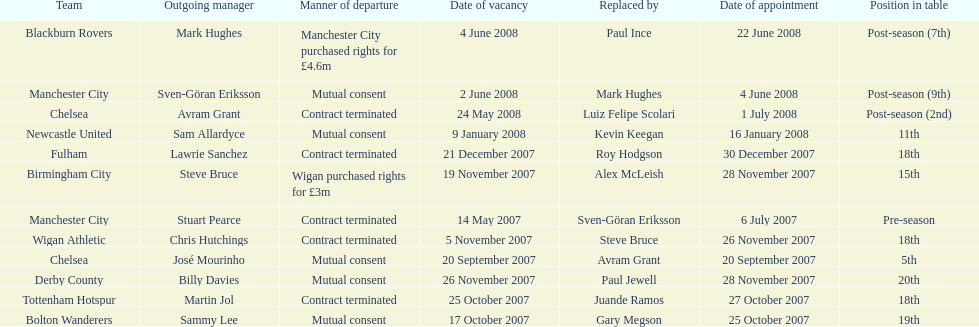Can you parse all the data within this table? {'header': ['Team', 'Outgoing manager', 'Manner of departure', 'Date of vacancy', 'Replaced by', 'Date of appointment', 'Position in table'], 'rows': [['Blackburn Rovers', 'Mark Hughes', 'Manchester City purchased rights for £4.6m', '4 June 2008', 'Paul Ince', '22 June 2008', 'Post-season (7th)'], ['Manchester City', 'Sven-Göran Eriksson', 'Mutual consent', '2 June 2008', 'Mark Hughes', '4 June 2008', 'Post-season (9th)'], ['Chelsea', 'Avram Grant', 'Contract terminated', '24 May 2008', 'Luiz Felipe Scolari', '1 July 2008', 'Post-season (2nd)'], ['Newcastle United', 'Sam Allardyce', 'Mutual consent', '9 January 2008', 'Kevin Keegan', '16 January 2008', '11th'], ['Fulham', 'Lawrie Sanchez', 'Contract terminated', '21 December 2007', 'Roy Hodgson', '30 December 2007', '18th'], ['Birmingham City', 'Steve Bruce', 'Wigan purchased rights for £3m', '19 November 2007', 'Alex McLeish', '28 November 2007', '15th'], ['Manchester City', 'Stuart Pearce', 'Contract terminated', '14 May 2007', 'Sven-Göran Eriksson', '6 July 2007', 'Pre-season'], ['Wigan Athletic', 'Chris Hutchings', 'Contract terminated', '5 November 2007', 'Steve Bruce', '26 November 2007', '18th'], ['Chelsea', 'José Mourinho', 'Mutual consent', '20 September 2007', 'Avram Grant', '20 September 2007', '5th'], ['Derby County', 'Billy Davies', 'Mutual consent', '26 November 2007', 'Paul Jewell', '28 November 2007', '20th'], ['Tottenham Hotspur', 'Martin Jol', 'Contract terminated', '25 October 2007', 'Juande Ramos', '27 October 2007', '18th'], ['Bolton Wanderers', 'Sammy Lee', 'Mutual consent', '17 October 2007', 'Gary Megson', '25 October 2007', '19th']]} What team is listed after manchester city? Chelsea. 